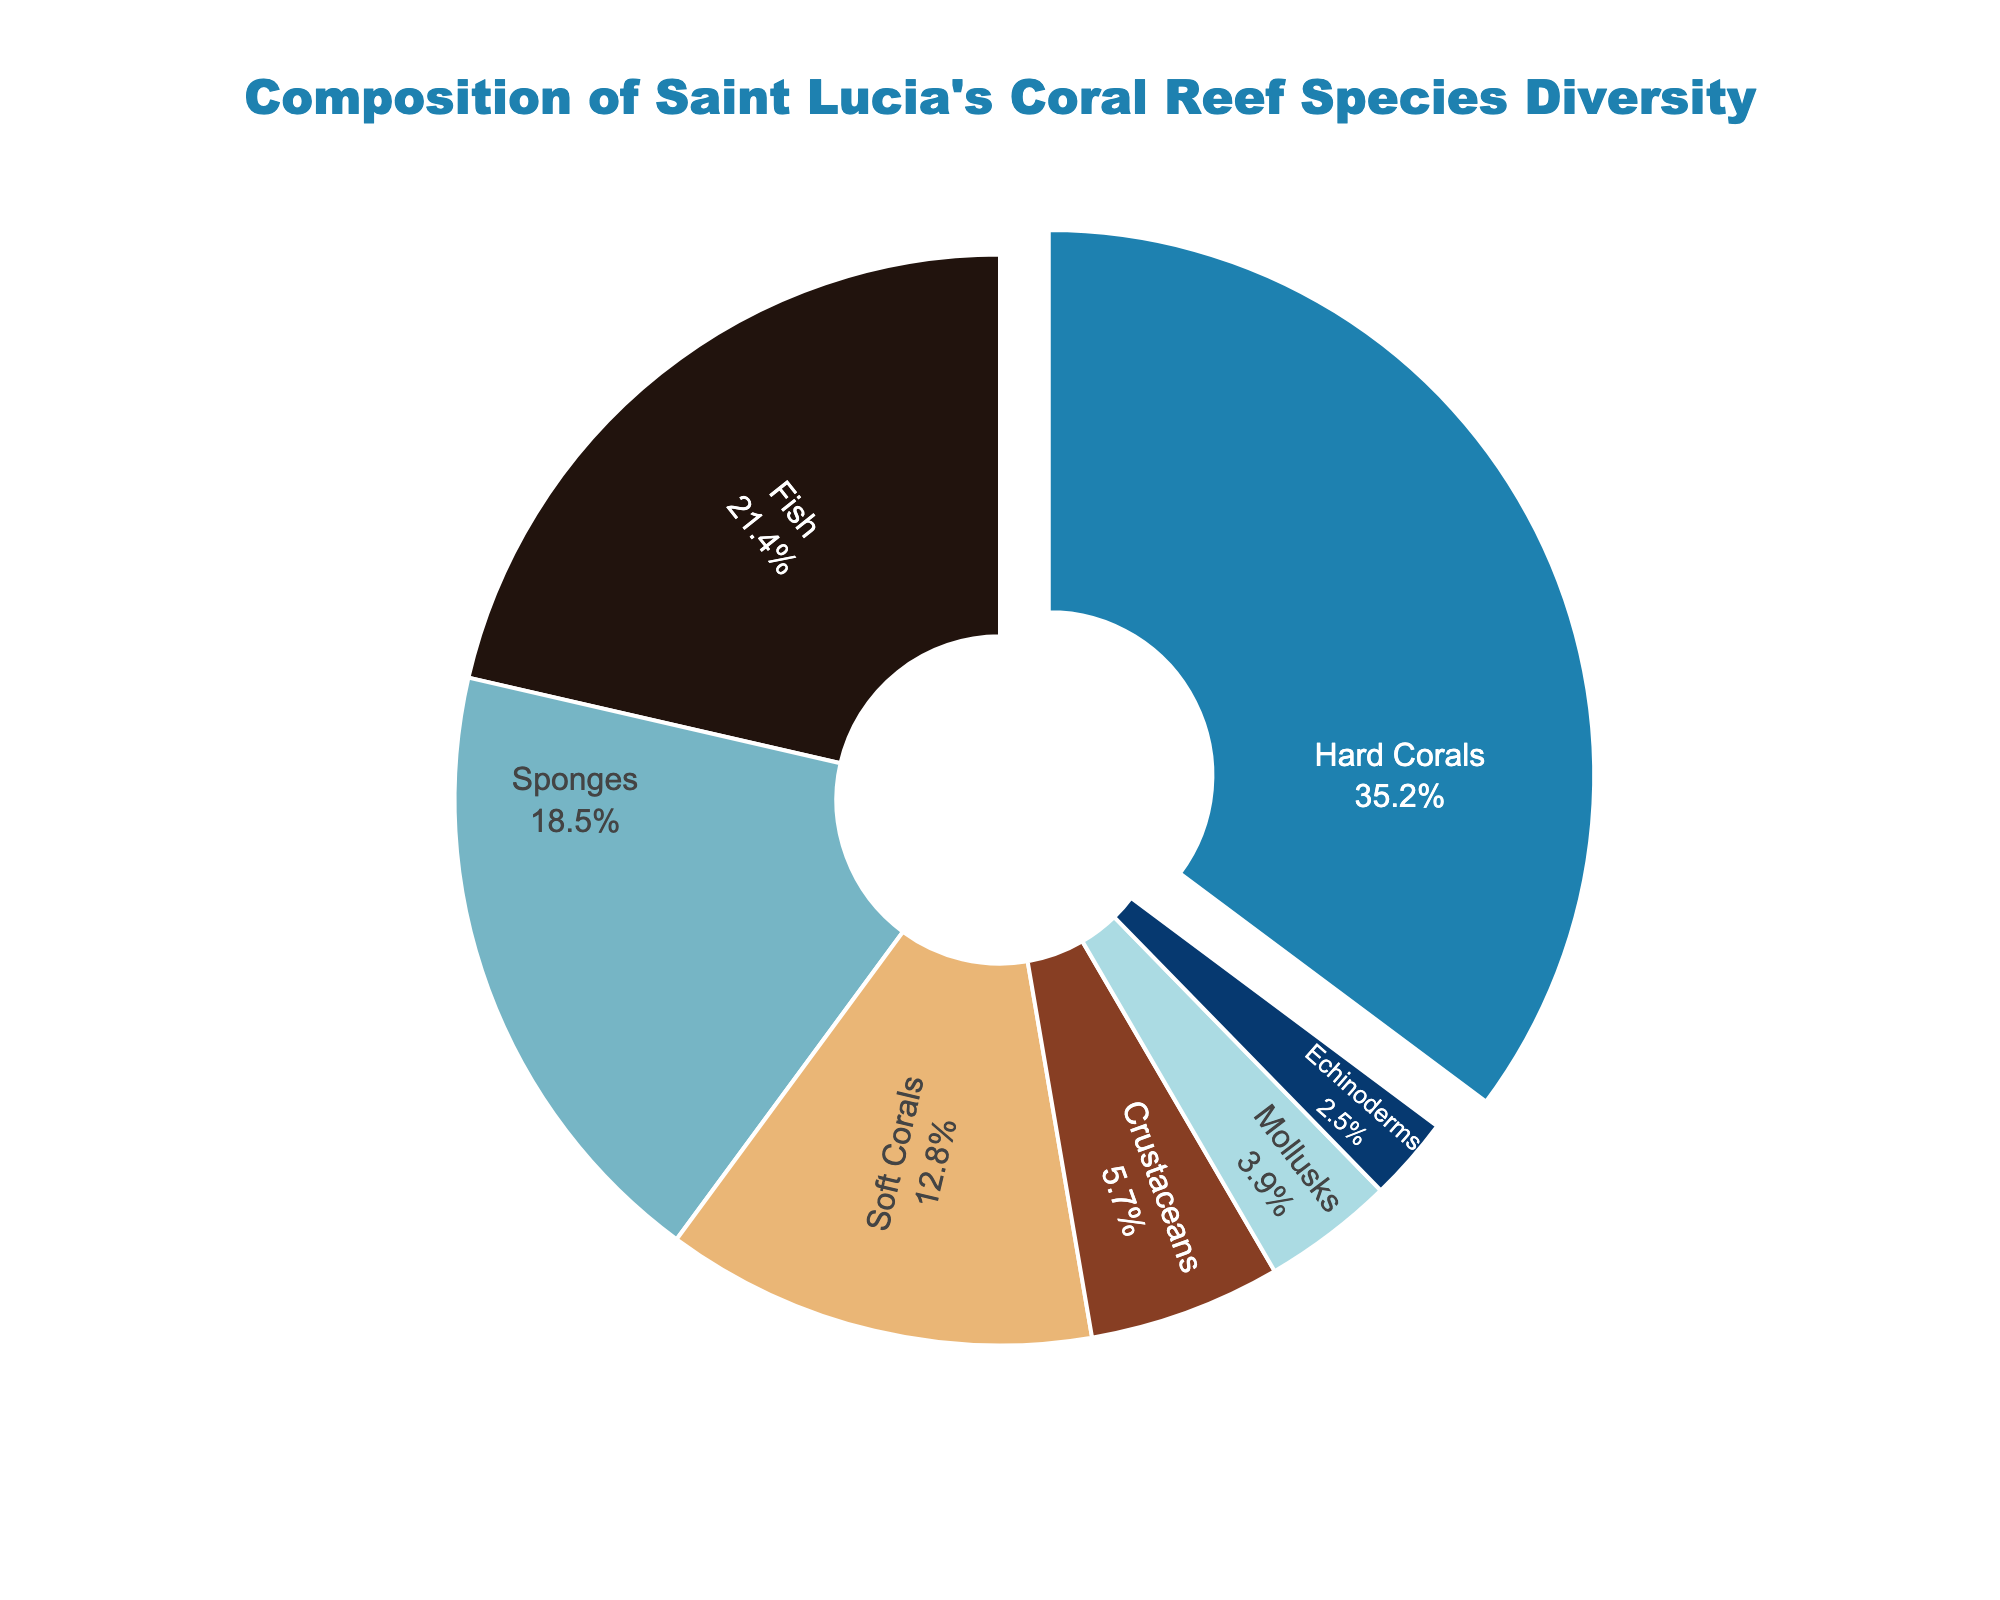What percentage of Saint Lucia's coral reef species diversity is accounted for by Hard Corals and Fish combined? Hard Corals account for 35.2% and Fish account for 21.4%. To find the combined percentage, add 35.2 + 21.4 = 56.6%.
Answer: 56.6% Which species category has the least representation in Saint Lucia's coral reef species diversity? By examining the figure, we see that Echinoderms have the smallest slice. Echinoderms account for 2.5%.
Answer: Echinoderms Among Sponges, Fish, and Crustaceans, which species group has the highest representation? Fish is represented by 21.4%, Sponges by 18.5%, and Crustaceans by 5.7%. Fish has the highest percentage amongst these groups.
Answer: Fish How much more representation do Hard Corals have compared to Mollusks? Hard Corals have 35.2% and Mollusks have 3.9%. Subtract 3.9 from 35.2 to find the difference: 35.2 - 3.9 = 31.3%.
Answer: 31.3% What are the category colors of Sponges and Crustaceans in the pie chart? In the pie chart, Sponges are represented by a light blue color and Crustaceans are represented by a brown color.
Answer: light blue and brown If we combine the percentages of Sponges, Fish, and Echinoderms, what would be their total contribution to the coral reef species diversity? Adding the percentages of Sponges (18.5%), Fish (21.4%), and Echinoderms (2.5%): 18.5 + 21.4 + 2.5 = 42.4%.
Answer: 42.4% Which species group has a slightly larger representation, Soft Corals or Crustaceans? Soft Corals have 12.8% and Crustaceans have 5.7%. Soft Corals have a larger representation.
Answer: Soft Corals What is the visual difference in percentage size between the largest segment and the smallest segment? The largest segment is Hard Corals (35.2%) and the smallest is Echinoderms (2.5%). The difference is 35.2 - 2.5 = 32.7%.
Answer: 32.7% Which species group has the second-highest representation in the coral reef species diversity? The highest category is Hard Corals with 35.2%. The second-highest is Fish with 21.4%.
Answer: Fish 